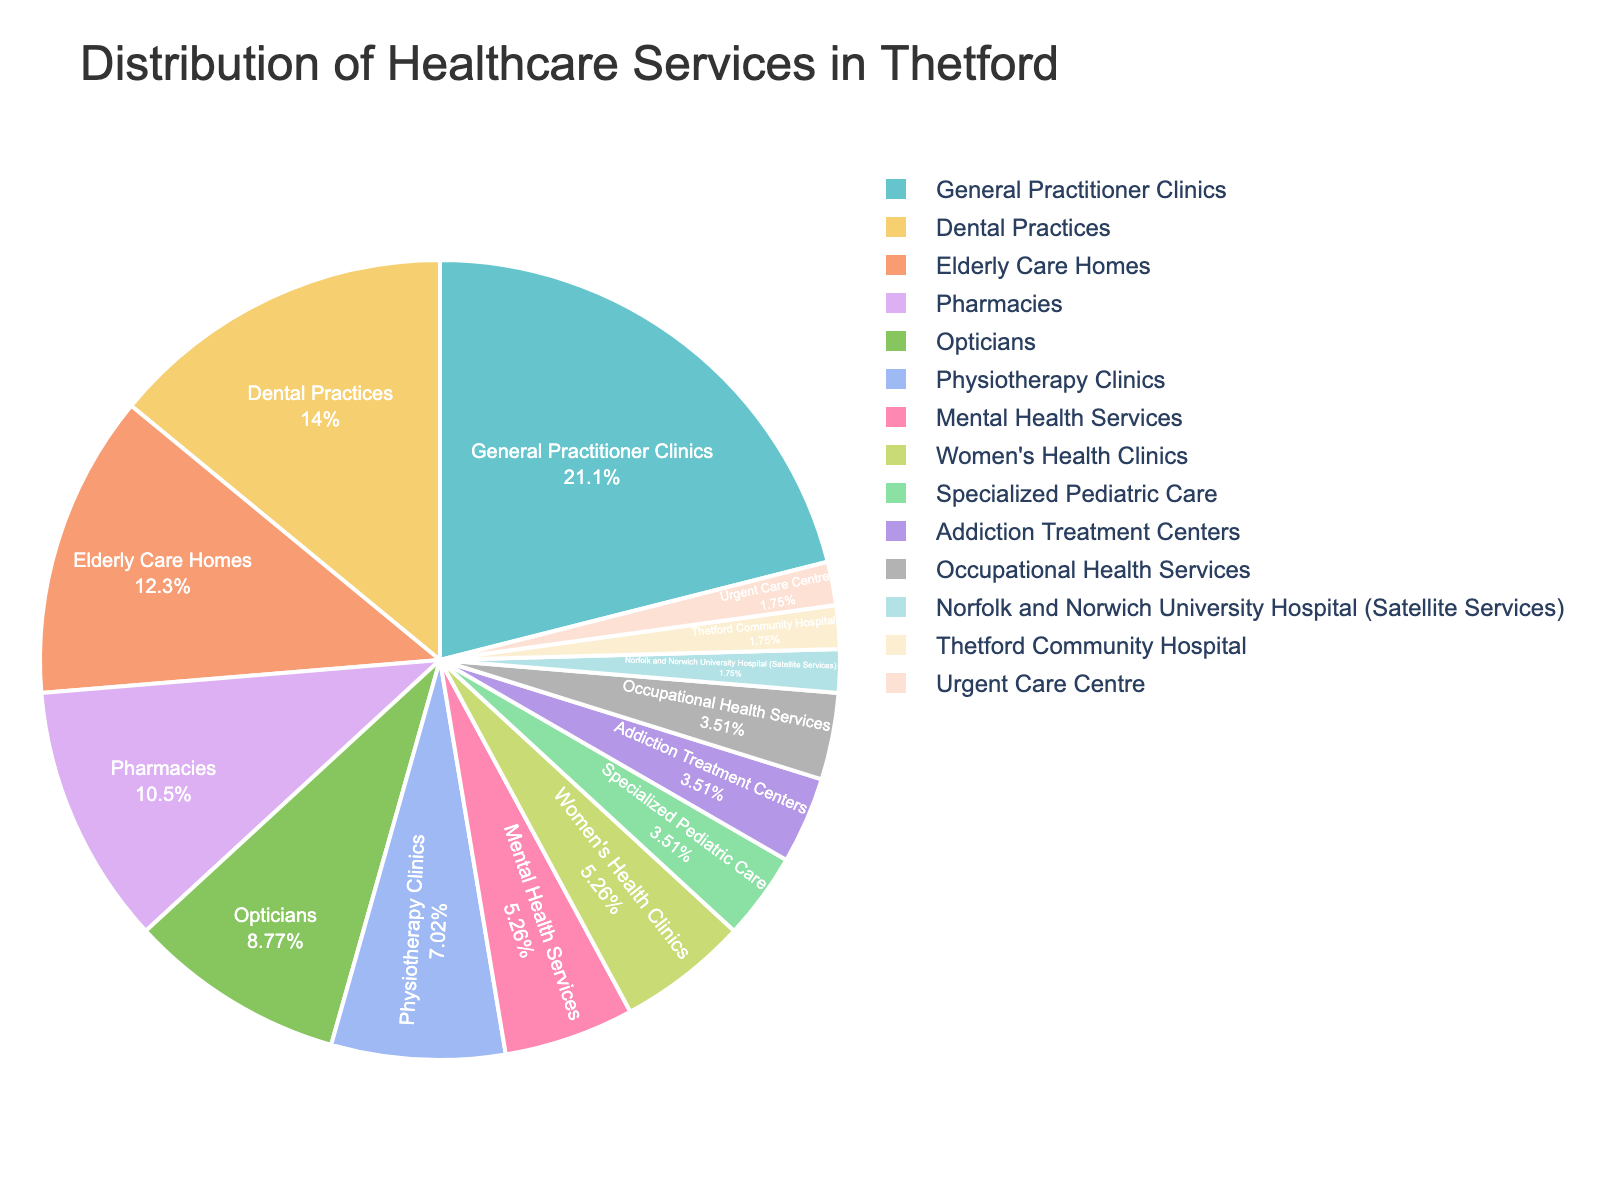What is the healthcare service type with the highest number of facilities? The pie chart segments show different healthcare types with their corresponding numbers. The segment for "General Practitioner Clinics" appears the largest, indicating it has the highest number of facilities.
Answer: General Practitioner Clinics Which two healthcare service types have the same number of facilities? By looking at segments of equal size, "Specialized Pediatric Care" and "Addiction Treatment Centers" both have segments of identical size, suggesting they have the same number of facilities.
Answer: Specialized Pediatric Care and Addiction Treatment Centers How do the numbers of Dental Practices and Pharmacies compare? By comparing the sizes of the segments, "Dental Practices" has a larger segment than "Pharmacies." This means there are more Dental Practices than Pharmacies.
Answer: Dental Practices are more than Pharmacies What percentage of healthcare facilities in Thetford are General Practitioner Clinics? The slice labeled "General Practitioner Clinics" indicates the proportion of this type. For exact percentages, the chart shows the bulk data.
Answer: 24% What colors are used to represent Women's Health Clinics and Opticians, and how many facilities are there for each? Refer to the legend and the corresponding segments. Women’s Health Clinics and Opticians will each have a unique color and their segment sizes indicate the number of facilities; Women's Health Clinics have 3 facilities and Optarians have 5 facilities; colors depend on the provided chart.
Answer: Women's Health Clinics and Opticians have 3 and 5 facilities, respectively What is the combined total number of facilities for Mental Health Services and Physiotherapy Clinics? Sum the numbers for "Mental Health Services" (3) and "Physiotherapy Clinics" (4).
Answer: 7 Which healthcare service type has the fewest facilities, and how many are there? The smallest segment, which is "Norfolk and Norwich University Hospital (Satellite Services)," has only one facility, same as Thetford Community Hospital, and Urgent Care Centre.
Answer: 1 What is the difference in the number of facilities between General Practitioner Clinics and Dental Practices? Subtract the number of "Dental Practices" (8) from "General Practitioner Clinics" (12).
Answer: 4 How many healthcare facilities are there altogether in Thetford? Sum all the numbers provided for each healthcare type. 12 + 1 + 1 + 8 + 6 + 3 + 4 + 5 + 7 + 1 + 2 + 3 + 2 + 2 = 57
Answer: 57 Which healthcare services have more facilities: Opticians or  Elderly Care Homes? By comparing the segments, "Elderly Care Homes" has more facilities (7) compared to "Opticians" (5).
Answer: Elderly Care Homes 